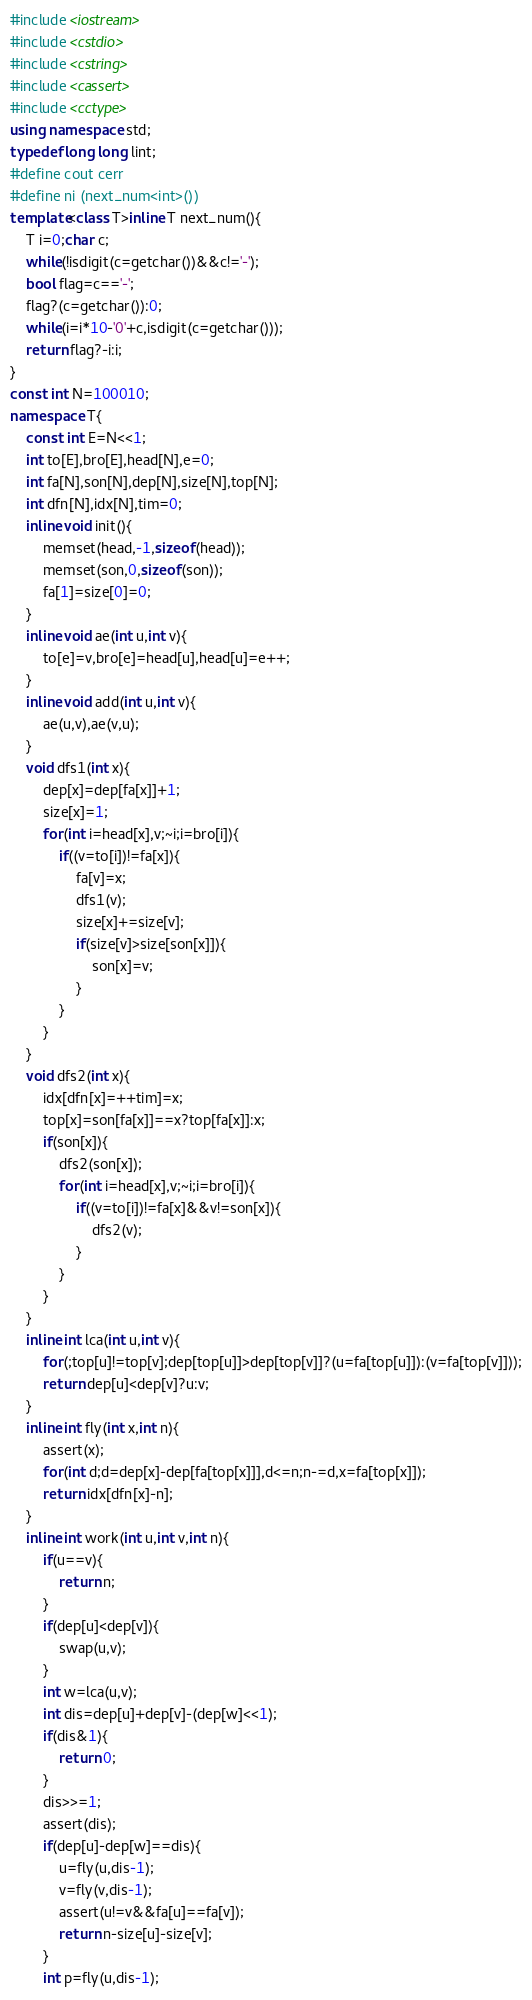<code> <loc_0><loc_0><loc_500><loc_500><_C++_>#include <iostream>
#include <cstdio>
#include <cstring>
#include <cassert>
#include <cctype>
using namespace std;
typedef long long lint;
#define cout cerr
#define ni (next_num<int>())
template<class T>inline T next_num(){
	T i=0;char c;
	while(!isdigit(c=getchar())&&c!='-');
	bool flag=c=='-';
	flag?(c=getchar()):0;
	while(i=i*10-'0'+c,isdigit(c=getchar()));
	return flag?-i:i;
}
const int N=100010;
namespace T{
	const int E=N<<1;
	int to[E],bro[E],head[N],e=0;
	int fa[N],son[N],dep[N],size[N],top[N];
	int dfn[N],idx[N],tim=0;
	inline void init(){
		memset(head,-1,sizeof(head));
		memset(son,0,sizeof(son));
		fa[1]=size[0]=0;
	}
	inline void ae(int u,int v){
		to[e]=v,bro[e]=head[u],head[u]=e++;
	}
	inline void add(int u,int v){
		ae(u,v),ae(v,u);
	}
	void dfs1(int x){
		dep[x]=dep[fa[x]]+1;
		size[x]=1;
		for(int i=head[x],v;~i;i=bro[i]){
			if((v=to[i])!=fa[x]){
				fa[v]=x;
				dfs1(v);
				size[x]+=size[v];
				if(size[v]>size[son[x]]){
					son[x]=v;
				}
			}
		}
	}
	void dfs2(int x){
		idx[dfn[x]=++tim]=x;
		top[x]=son[fa[x]]==x?top[fa[x]]:x;
		if(son[x]){
			dfs2(son[x]);
			for(int i=head[x],v;~i;i=bro[i]){
				if((v=to[i])!=fa[x]&&v!=son[x]){
					dfs2(v);
				}
			}
		}
	}
	inline int lca(int u,int v){
		for(;top[u]!=top[v];dep[top[u]]>dep[top[v]]?(u=fa[top[u]]):(v=fa[top[v]]));
		return dep[u]<dep[v]?u:v;
	}
	inline int fly(int x,int n){
		assert(x);
		for(int d;d=dep[x]-dep[fa[top[x]]],d<=n;n-=d,x=fa[top[x]]);
		return idx[dfn[x]-n];
	}
	inline int work(int u,int v,int n){
		if(u==v){
			return n;
		}
		if(dep[u]<dep[v]){
			swap(u,v);
		}
		int w=lca(u,v);
		int dis=dep[u]+dep[v]-(dep[w]<<1);
		if(dis&1){
			return 0;
		}
		dis>>=1;
		assert(dis);
		if(dep[u]-dep[w]==dis){
			u=fly(u,dis-1);
			v=fly(v,dis-1);
			assert(u!=v&&fa[u]==fa[v]);
			return n-size[u]-size[v];
		}
		int p=fly(u,dis-1);</code> 